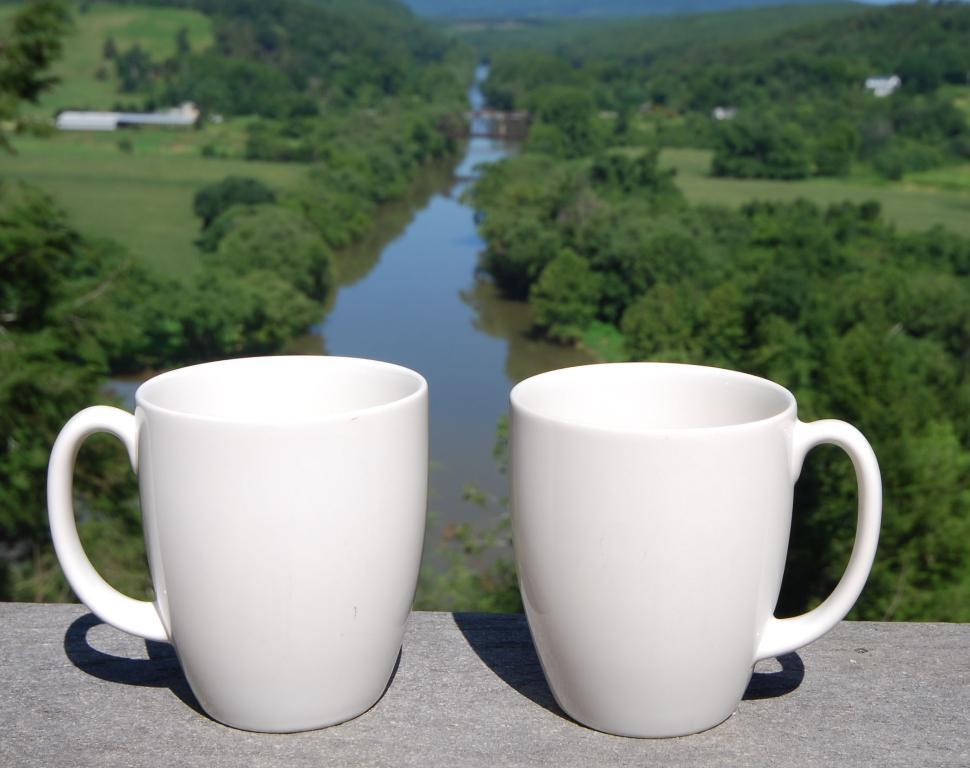What objects are present in the image? There are cups in the image. What can be seen in the background of the image? There is water and trees visible in the background of the image. What type of line can be seen on the moon in the image? There is no moon present in the image, so there is no line on the moon to be seen. 